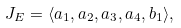Convert formula to latex. <formula><loc_0><loc_0><loc_500><loc_500>J _ { E } = \langle a _ { 1 } , a _ { 2 } , a _ { 3 } , a _ { 4 } , b _ { 1 } \rangle ,</formula> 